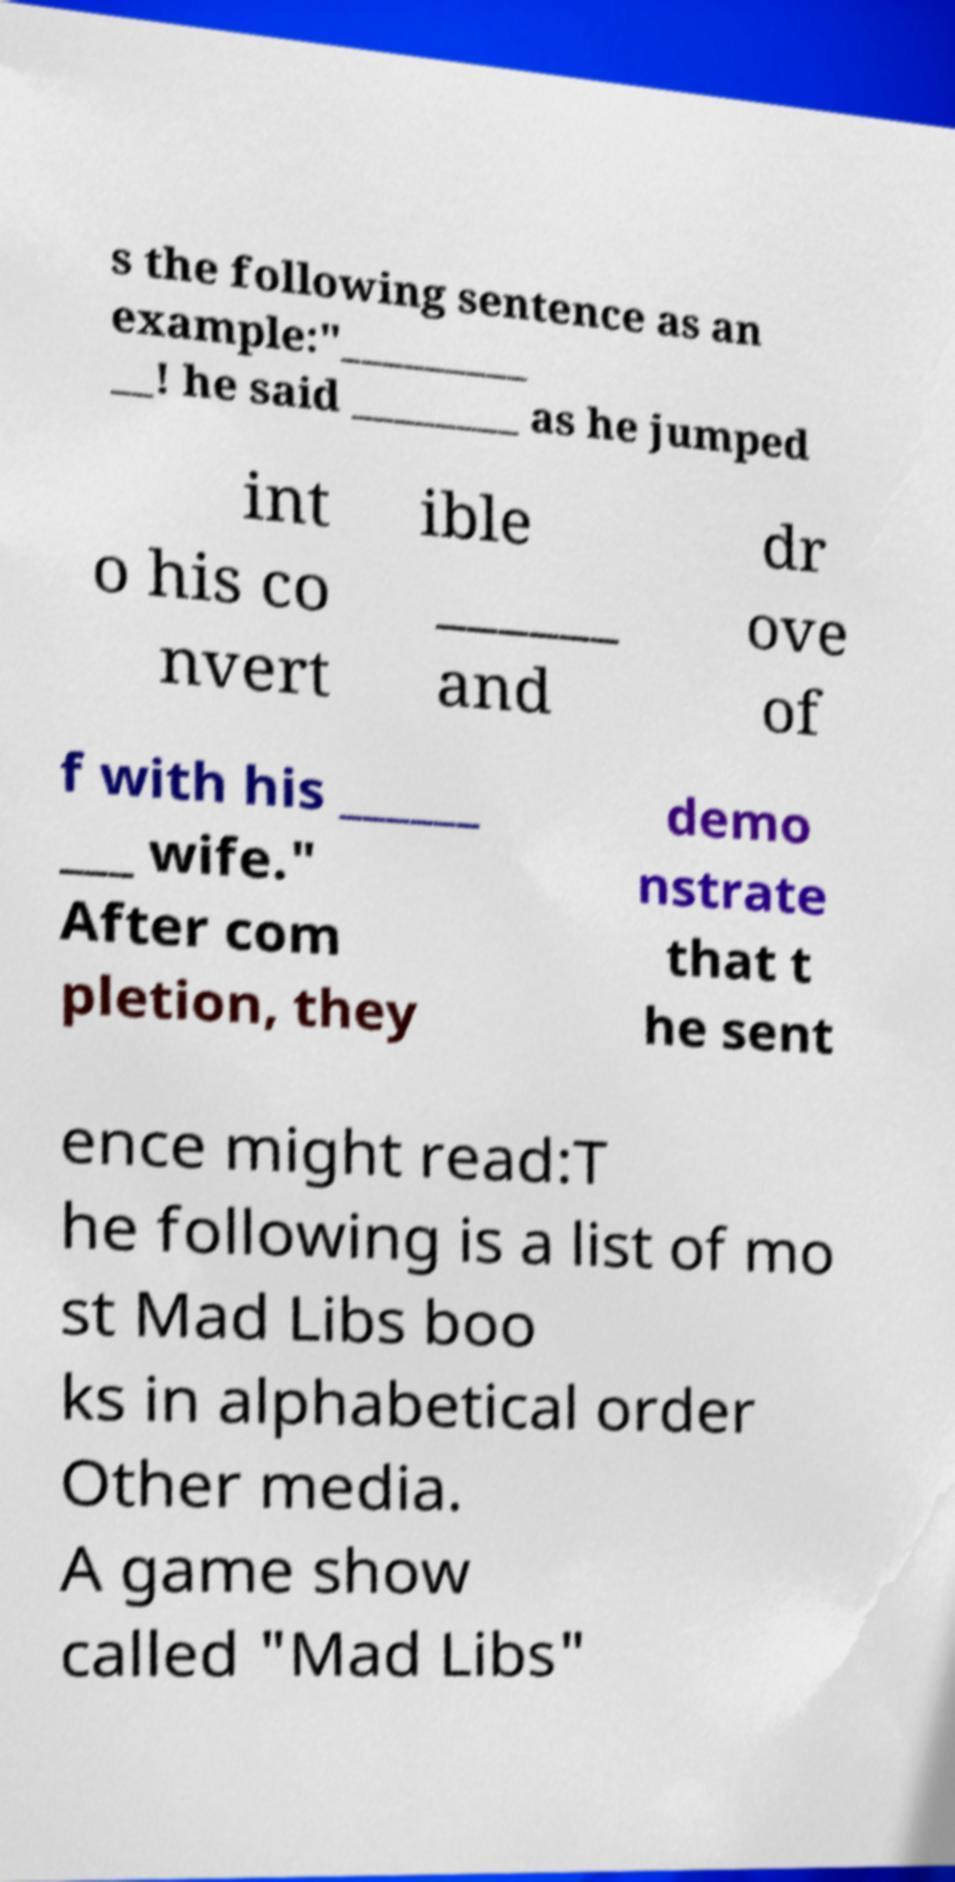Could you extract and type out the text from this image? s the following sentence as an example:"_________ __! he said ________ as he jumped int o his co nvert ible ______ and dr ove of f with his ______ ___ wife." After com pletion, they demo nstrate that t he sent ence might read:T he following is a list of mo st Mad Libs boo ks in alphabetical order Other media. A game show called "Mad Libs" 